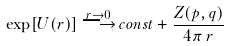Convert formula to latex. <formula><loc_0><loc_0><loc_500><loc_500>\exp [ U ( r ) ] \, { \stackrel { r \to 0 } { \longrightarrow } } \, c o n s t + \frac { Z ( p , q ) } { 4 \pi \, r }</formula> 